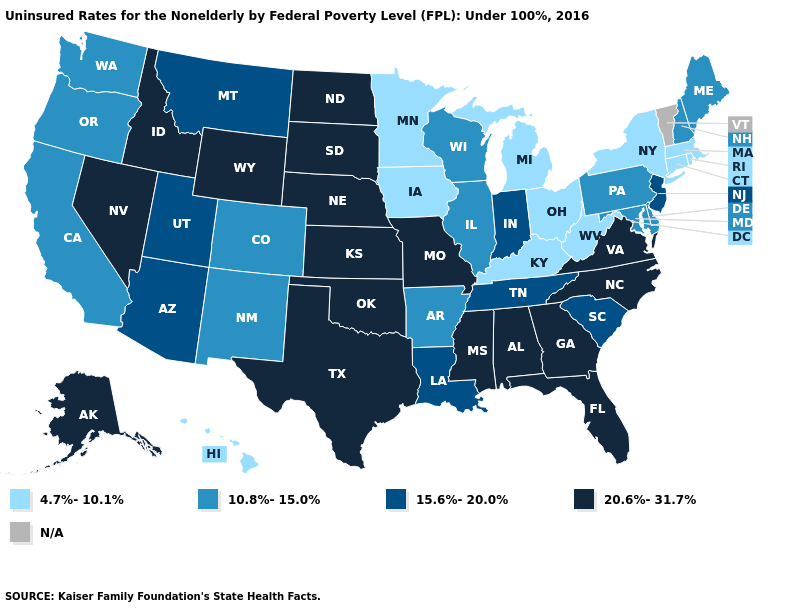What is the lowest value in the USA?
Quick response, please. 4.7%-10.1%. Among the states that border Virginia , which have the lowest value?
Write a very short answer. Kentucky, West Virginia. How many symbols are there in the legend?
Short answer required. 5. Does the first symbol in the legend represent the smallest category?
Write a very short answer. Yes. Does the map have missing data?
Be succinct. Yes. Is the legend a continuous bar?
Answer briefly. No. How many symbols are there in the legend?
Concise answer only. 5. Does the first symbol in the legend represent the smallest category?
Short answer required. Yes. Name the states that have a value in the range 10.8%-15.0%?
Write a very short answer. Arkansas, California, Colorado, Delaware, Illinois, Maine, Maryland, New Hampshire, New Mexico, Oregon, Pennsylvania, Washington, Wisconsin. Among the states that border Delaware , does New Jersey have the lowest value?
Short answer required. No. What is the lowest value in states that border Illinois?
Answer briefly. 4.7%-10.1%. Which states have the highest value in the USA?
Be succinct. Alabama, Alaska, Florida, Georgia, Idaho, Kansas, Mississippi, Missouri, Nebraska, Nevada, North Carolina, North Dakota, Oklahoma, South Dakota, Texas, Virginia, Wyoming. 